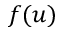<formula> <loc_0><loc_0><loc_500><loc_500>f ( u )</formula> 